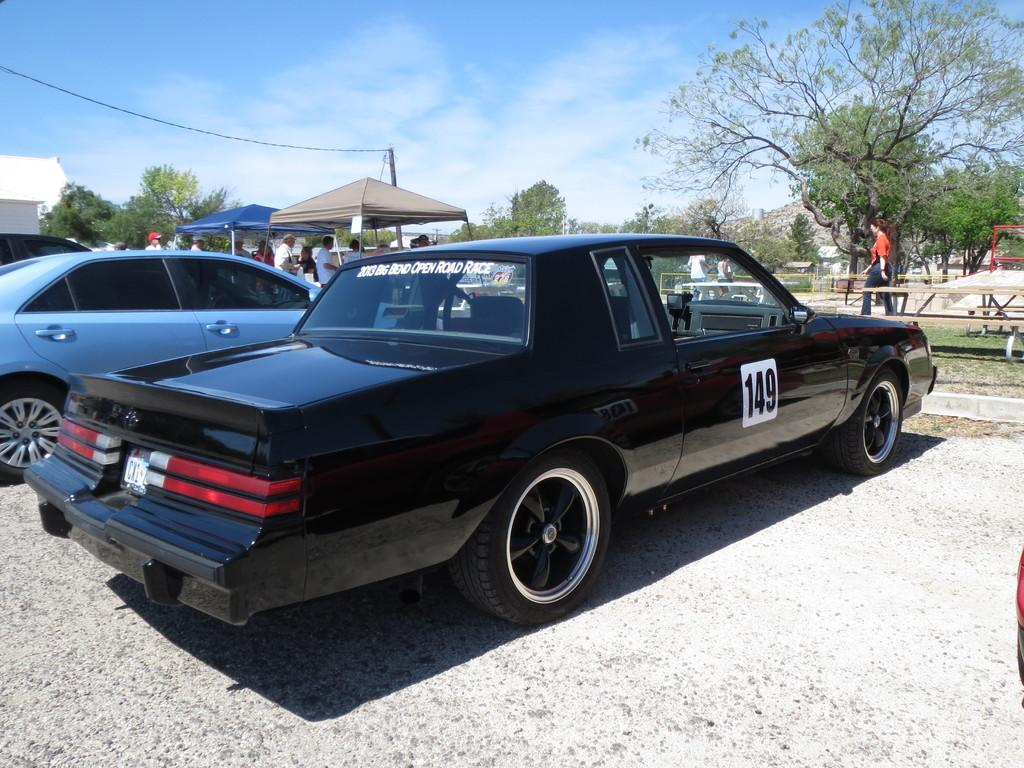What can be seen on the road in the image? There are cars on the road in the image. What type of vegetation is visible in the image? Grass is visible in the image. What type of seating is present in the image? There are benches in the image. What type of people can be seen in the image? There are people in the image. What type of temporary shelter is present in the image? There are tents in the image. What type of structure is present in the image? A pole is present in the image. What type of utility infrastructure is visible in the image? Wires are visible in the image. What type of natural scenery is visible in the background of the image? There are trees in the background of the image. What type of sky is visible in the background of the image? The sky is visible in the background of the image. Can you see a rifle in the image? No, there is no rifle present in the image. What type of bit is being used by the people in the image? There is no bit present in the image, as it is not related to the subjects or objects depicted. 